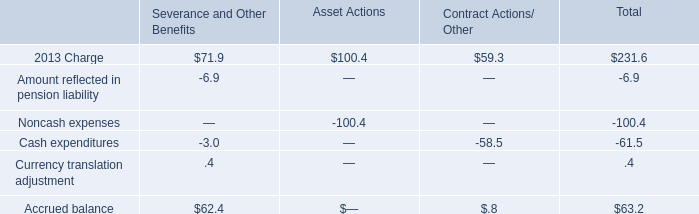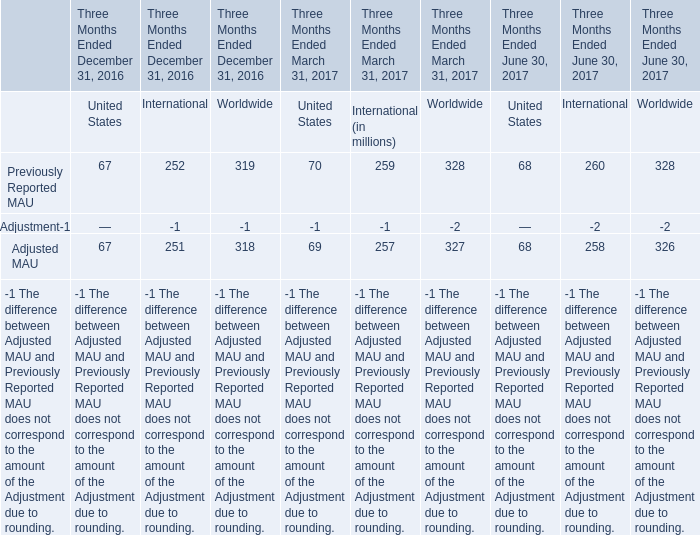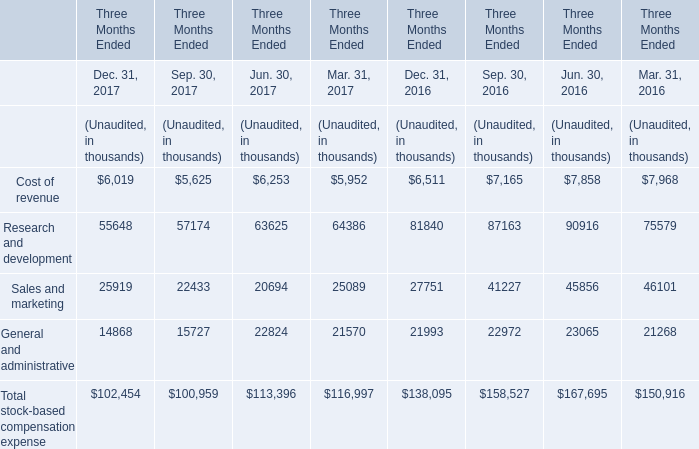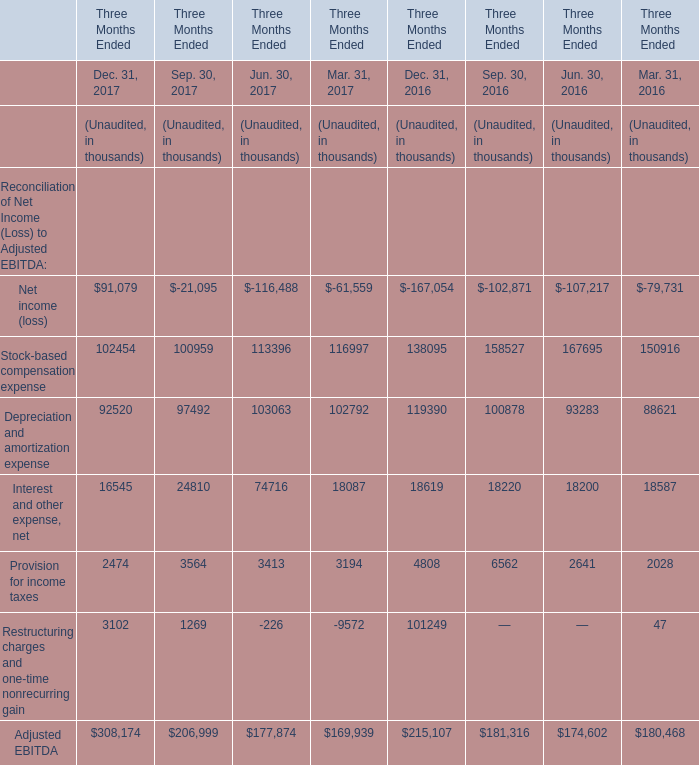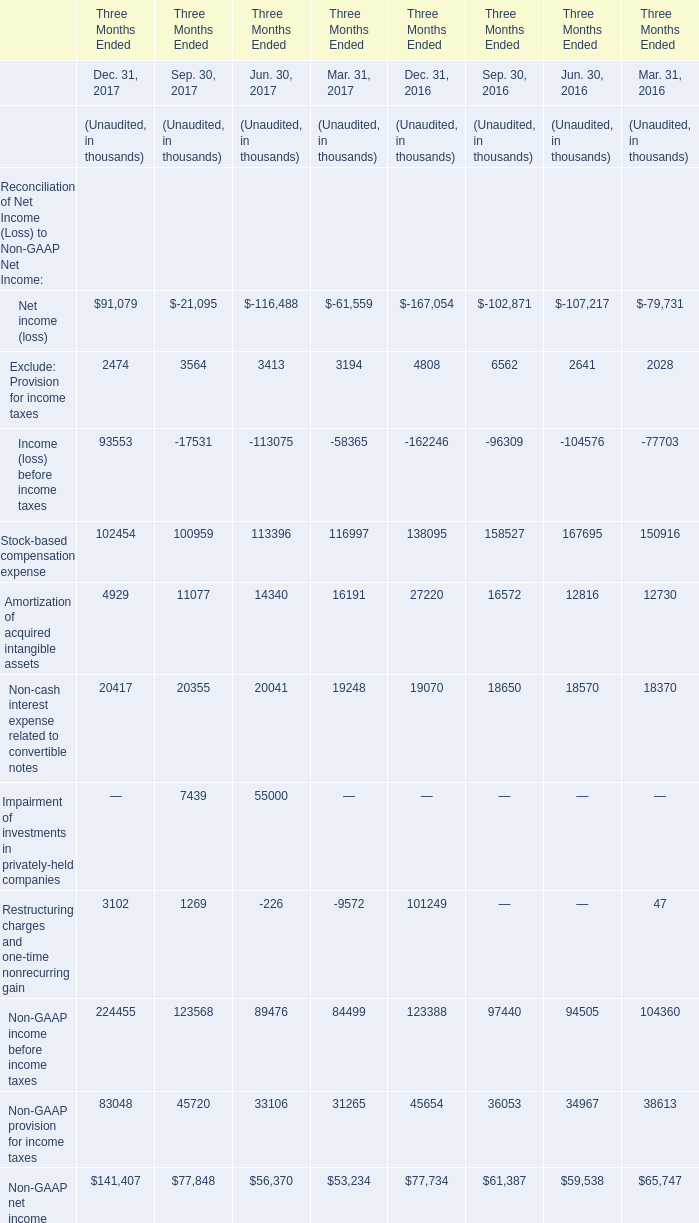If Interest and other expense, net develops with the same increasing rate in Dec. 31, 2017, what will it reach in 2018? (in thousand) 
Computations: ((((16545 - 18619) / 18619) + 1) * 16545)
Answer: 14702.02616. 